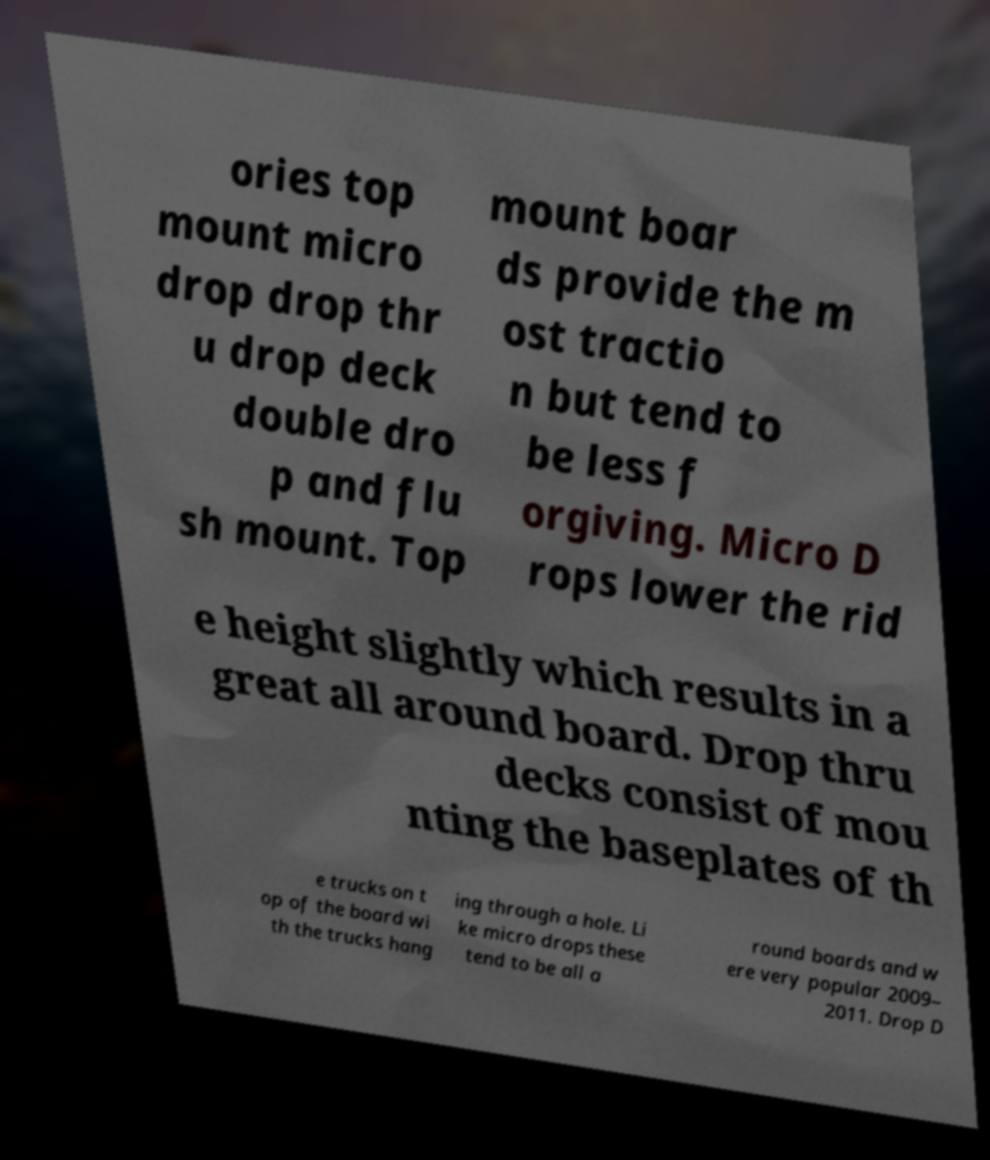Could you extract and type out the text from this image? ories top mount micro drop drop thr u drop deck double dro p and flu sh mount. Top mount boar ds provide the m ost tractio n but tend to be less f orgiving. Micro D rops lower the rid e height slightly which results in a great all around board. Drop thru decks consist of mou nting the baseplates of th e trucks on t op of the board wi th the trucks hang ing through a hole. Li ke micro drops these tend to be all a round boards and w ere very popular 2009– 2011. Drop D 